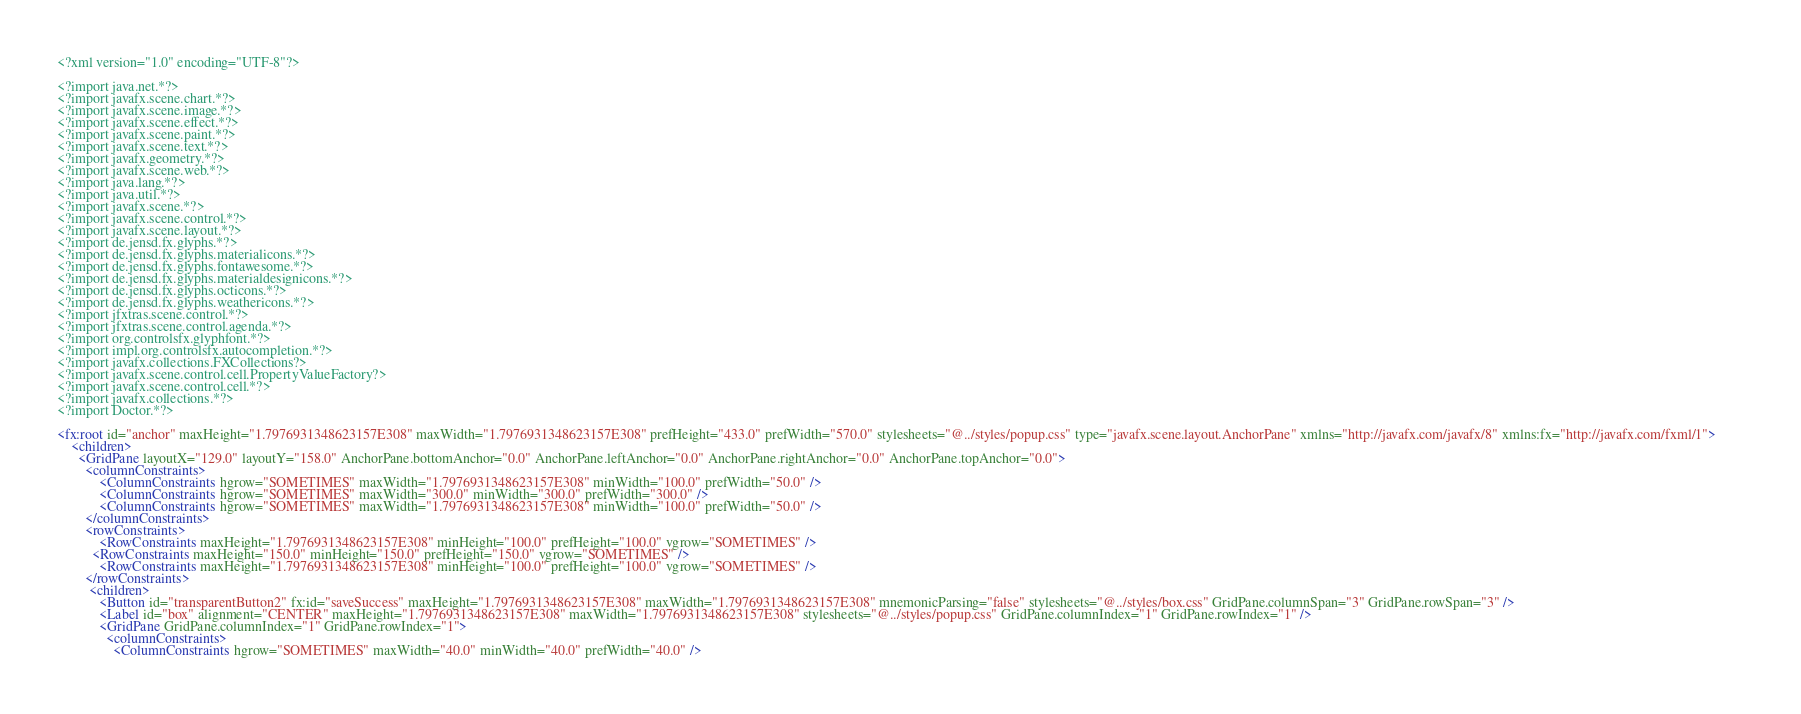<code> <loc_0><loc_0><loc_500><loc_500><_XML_><?xml version="1.0" encoding="UTF-8"?>

<?import java.net.*?>
<?import javafx.scene.chart.*?>
<?import javafx.scene.image.*?>
<?import javafx.scene.effect.*?>
<?import javafx.scene.paint.*?>
<?import javafx.scene.text.*?>
<?import javafx.geometry.*?>
<?import javafx.scene.web.*?>
<?import java.lang.*?>
<?import java.util.*?>
<?import javafx.scene.*?>
<?import javafx.scene.control.*?>
<?import javafx.scene.layout.*?>
<?import de.jensd.fx.glyphs.*?>
<?import de.jensd.fx.glyphs.materialicons.*?>
<?import de.jensd.fx.glyphs.fontawesome.*?>
<?import de.jensd.fx.glyphs.materialdesignicons.*?>
<?import de.jensd.fx.glyphs.octicons.*?>
<?import de.jensd.fx.glyphs.weathericons.*?>
<?import jfxtras.scene.control.*?>
<?import jfxtras.scene.control.agenda.*?>
<?import org.controlsfx.glyphfont.*?>
<?import impl.org.controlsfx.autocompletion.*?>
<?import javafx.collections.FXCollections?>
<?import javafx.scene.control.cell.PropertyValueFactory?>
<?import javafx.scene.control.cell.*?>
<?import javafx.collections.*?>
<?import Doctor.*?>

<fx:root id="anchor" maxHeight="1.7976931348623157E308" maxWidth="1.7976931348623157E308" prefHeight="433.0" prefWidth="570.0" stylesheets="@../styles/popup.css" type="javafx.scene.layout.AnchorPane" xmlns="http://javafx.com/javafx/8" xmlns:fx="http://javafx.com/fxml/1">        
    <children>
      <GridPane layoutX="129.0" layoutY="158.0" AnchorPane.bottomAnchor="0.0" AnchorPane.leftAnchor="0.0" AnchorPane.rightAnchor="0.0" AnchorPane.topAnchor="0.0">
        <columnConstraints>
            <ColumnConstraints hgrow="SOMETIMES" maxWidth="1.7976931348623157E308" minWidth="100.0" prefWidth="50.0" />
            <ColumnConstraints hgrow="SOMETIMES" maxWidth="300.0" minWidth="300.0" prefWidth="300.0" />
            <ColumnConstraints hgrow="SOMETIMES" maxWidth="1.7976931348623157E308" minWidth="100.0" prefWidth="50.0" />
        </columnConstraints>
        <rowConstraints>
            <RowConstraints maxHeight="1.7976931348623157E308" minHeight="100.0" prefHeight="100.0" vgrow="SOMETIMES" />
          <RowConstraints maxHeight="150.0" minHeight="150.0" prefHeight="150.0" vgrow="SOMETIMES" />
            <RowConstraints maxHeight="1.7976931348623157E308" minHeight="100.0" prefHeight="100.0" vgrow="SOMETIMES" />
        </rowConstraints>
         <children>
            <Button id="transparentButton2" fx:id="saveSuccess" maxHeight="1.7976931348623157E308" maxWidth="1.7976931348623157E308" mnemonicParsing="false" stylesheets="@../styles/box.css" GridPane.columnSpan="3" GridPane.rowSpan="3" />
            <Label id="box" alignment="CENTER" maxHeight="1.7976931348623157E308" maxWidth="1.7976931348623157E308" stylesheets="@../styles/popup.css" GridPane.columnIndex="1" GridPane.rowIndex="1" />
            <GridPane GridPane.columnIndex="1" GridPane.rowIndex="1">
              <columnConstraints>
                <ColumnConstraints hgrow="SOMETIMES" maxWidth="40.0" minWidth="40.0" prefWidth="40.0" /></code> 